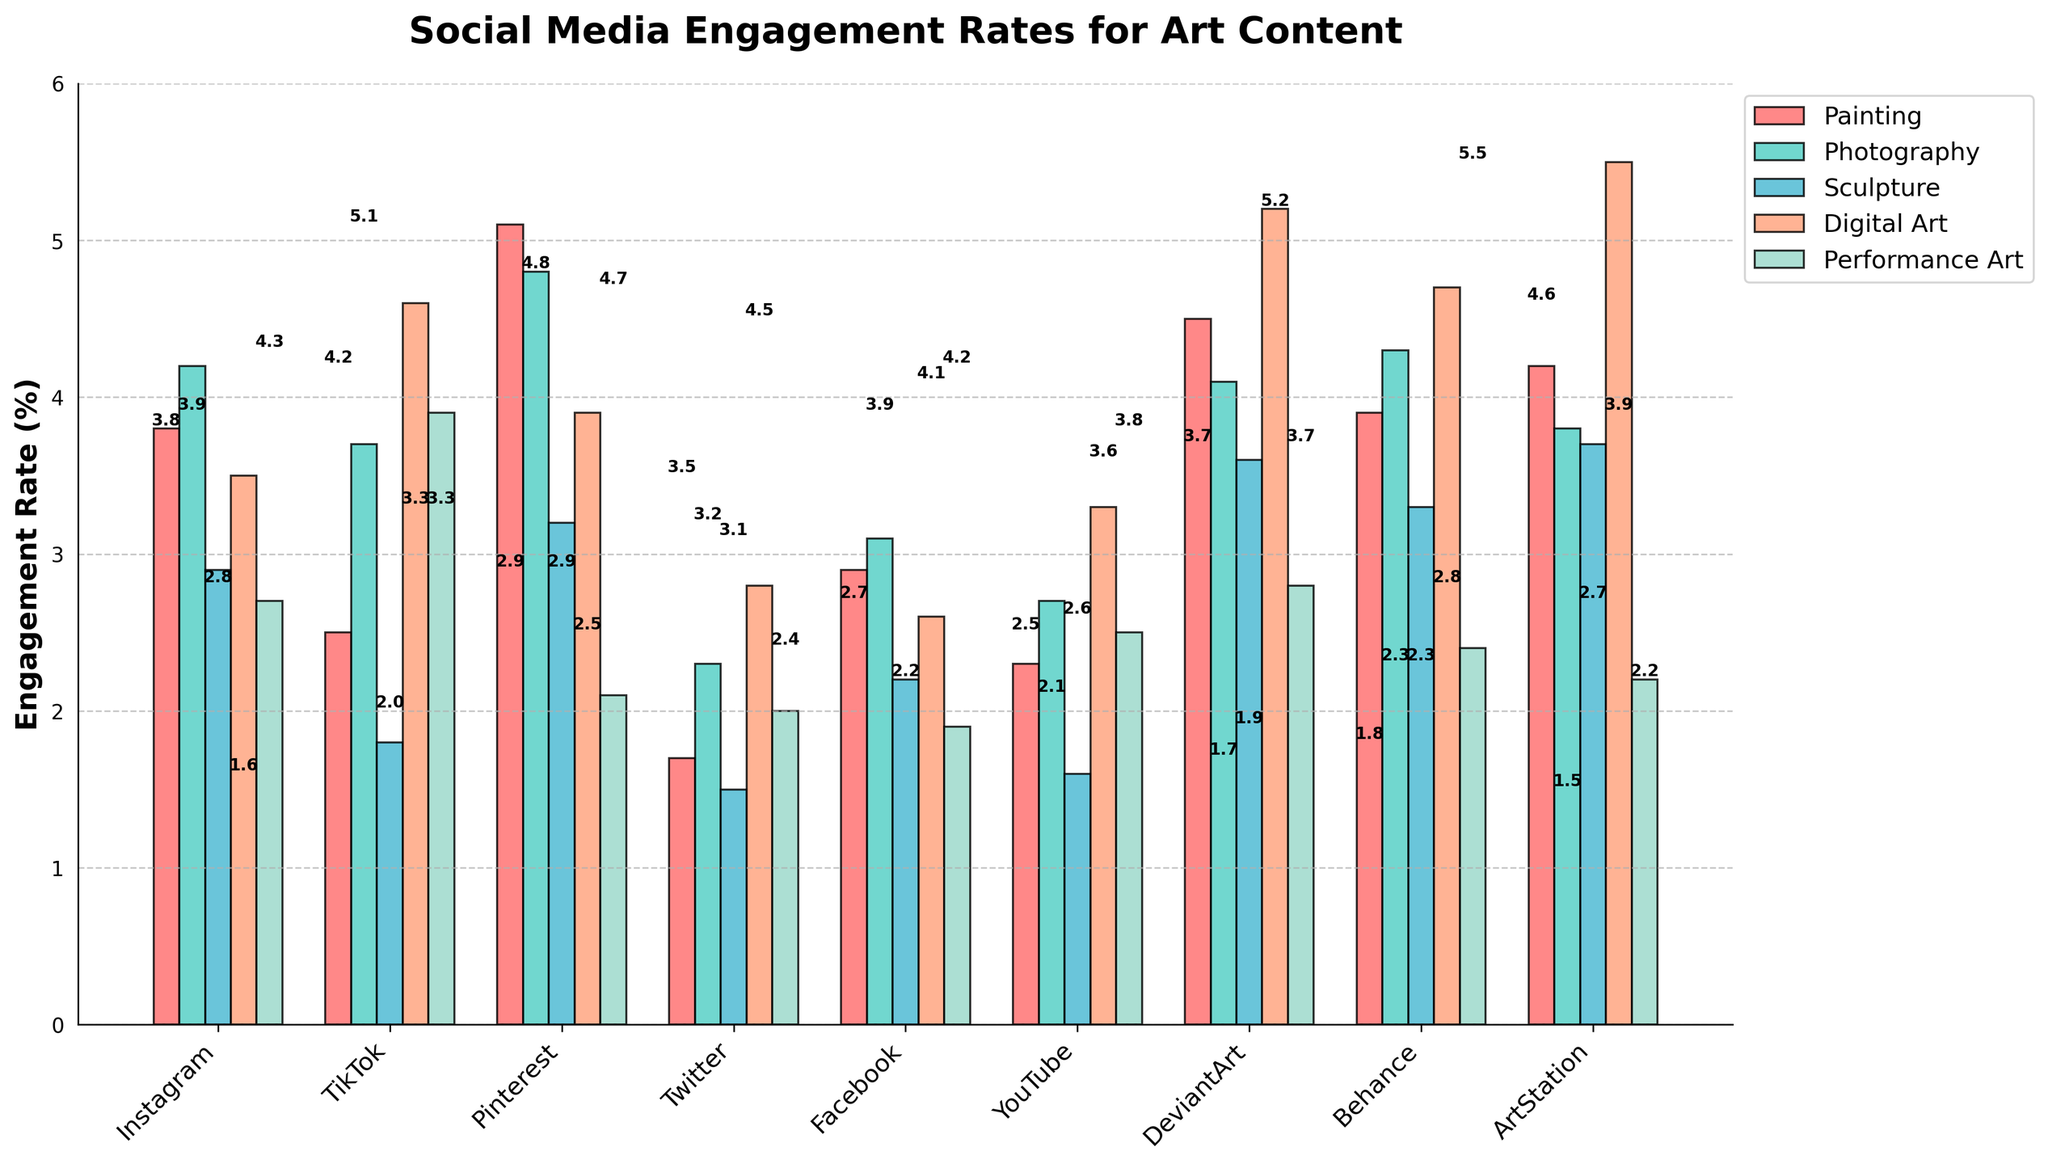Which platform has the highest engagement rate for Digital Art? Look for the highest bar in the Digital Art category. Among all platforms, ArtStation has the tallest bar, indicating the highest engagement rate for Digital Art.
Answer: ArtStation Which type of art content has the lowest engagement rate across all platforms? Look for the smallest bar across all art categories on the chart. The smallest bar is for Sculpture on Twitter, which shows an engagement rate of 1.5%.
Answer: Sculpture on Twitter What is the average engagement rate for Painting on Instagram, TikTok, and Pinterest? Sum the engagement rates for Painting on the three platforms and then divide by the number of platforms. (3.8 + 2.5 + 5.1) / 3 = 11.4 / 3 = 3.8
Answer: 3.8 Compare the engagement rates for Performance Art on Pinterest and Facebook. Which is higher? Compare the height of the bars for Performance Art on Pinterest and Facebook. Pinterest's bar is at 2.1, whereas Facebook's is at 1.9. Thus, Pinterest has a higher engagement rate for Performance Art.
Answer: Pinterest What is the difference in engagement rates for Photography between Instagram and DeviantArt? Subtract the engagement rate for Photography on DeviantArt from that on Instagram. 4.2 - 4.1 = 0.1
Answer: 0.1 Which platform has the most balanced engagement rates for all types of art content? Identify the platform where the bars are most evenly matched height-wise. DeviantArt has fairly balanced engagement rates across the different art categories compared to other platforms.
Answer: DeviantArt What is the range of engagement rates for Sculpture across all platforms? Find the maximum and minimum engagement rates for Sculpture and subtract the minimum from the maximum. The maximum is 3.7 (ArtStation), and the minimum is 1.5 (Twitter). 3.7 - 1.5 = 2.2
Answer: 2.2 How does the engagement rate for Digital Art on Behance compare to that on YouTube? Compare the height of the bars for Digital Art on Behance and YouTube. Behance's bar is at 4.7, while YouTube's is at 3.3. Behance's engagement rate is higher.
Answer: Behance What is the sum of engagement rates for Sculpture across Instagram, TikTok, and Pinterest? Add the engagement rates for Sculpture on these three platforms. 2.9 (Instagram) + 1.8 (TikTok) + 3.2 (Pinterest) = 7.9
Answer: 7.9 What is the median engagement rate for Platform DeviantArt across all types of art content? Arrange the engagement rates for DeviantArt (4.5, 4.1, 3.6, 5.2, 2.8) in ascending order (2.8, 3.6, 4.1, 4.5, 5.2). The median is the middle value, which is 4.1.
Answer: 4.1 